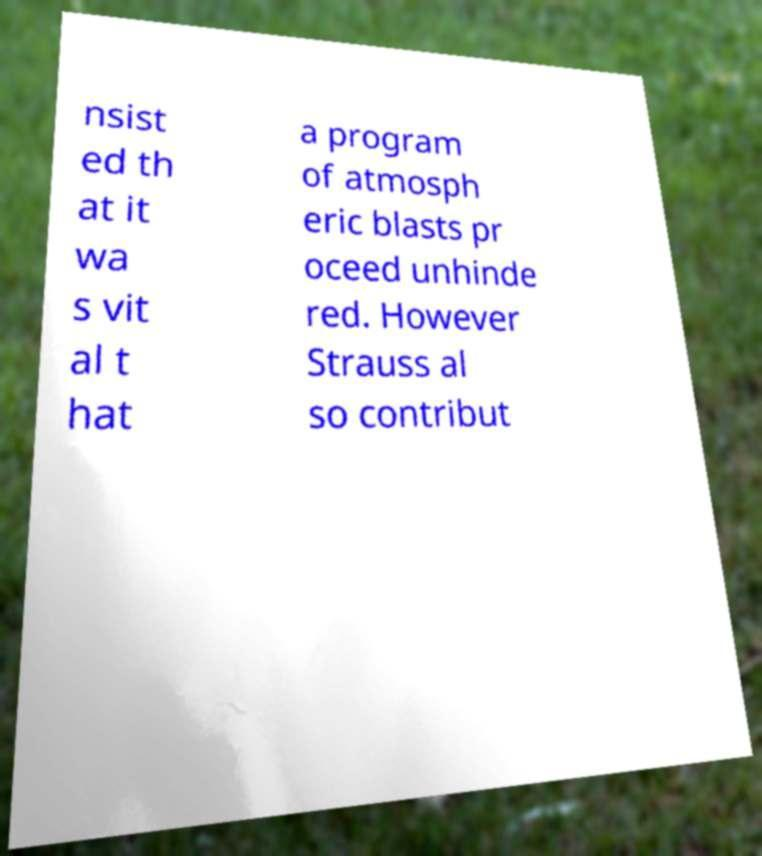Can you accurately transcribe the text from the provided image for me? nsist ed th at it wa s vit al t hat a program of atmosph eric blasts pr oceed unhinde red. However Strauss al so contribut 